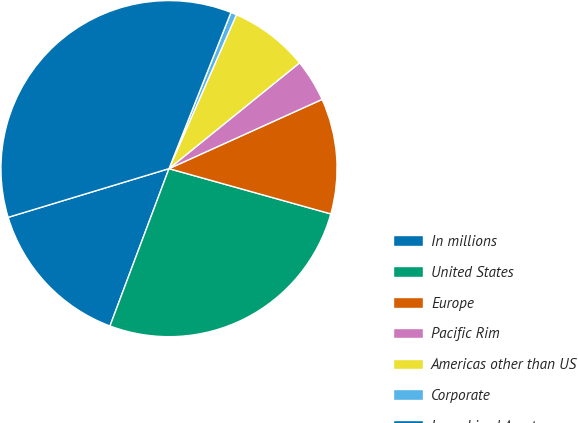<chart> <loc_0><loc_0><loc_500><loc_500><pie_chart><fcel>In millions<fcel>United States<fcel>Europe<fcel>Pacific Rim<fcel>Americas other than US<fcel>Corporate<fcel>Long-Lived Assets<nl><fcel>14.61%<fcel>26.37%<fcel>11.1%<fcel>4.08%<fcel>7.59%<fcel>0.56%<fcel>35.69%<nl></chart> 